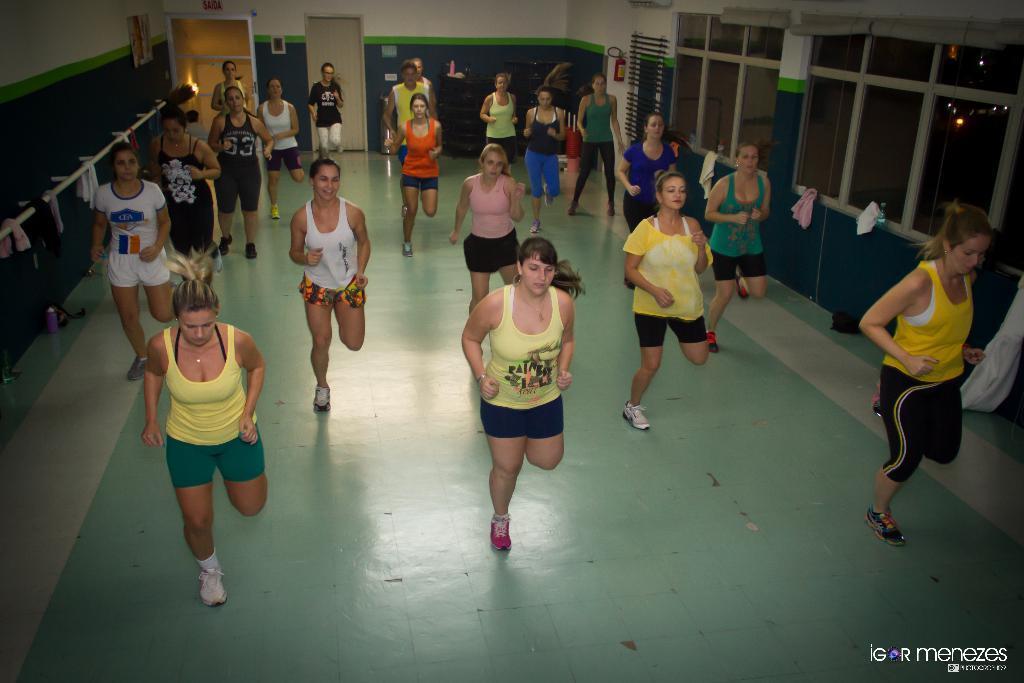In one or two sentences, can you explain what this image depicts? In the image it looks like the people are doing some fitness exercises and on the right side there are windows, on the left side there are some clothes kept on a white rod, in the background there is an exit door. 